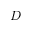<formula> <loc_0><loc_0><loc_500><loc_500>D</formula> 